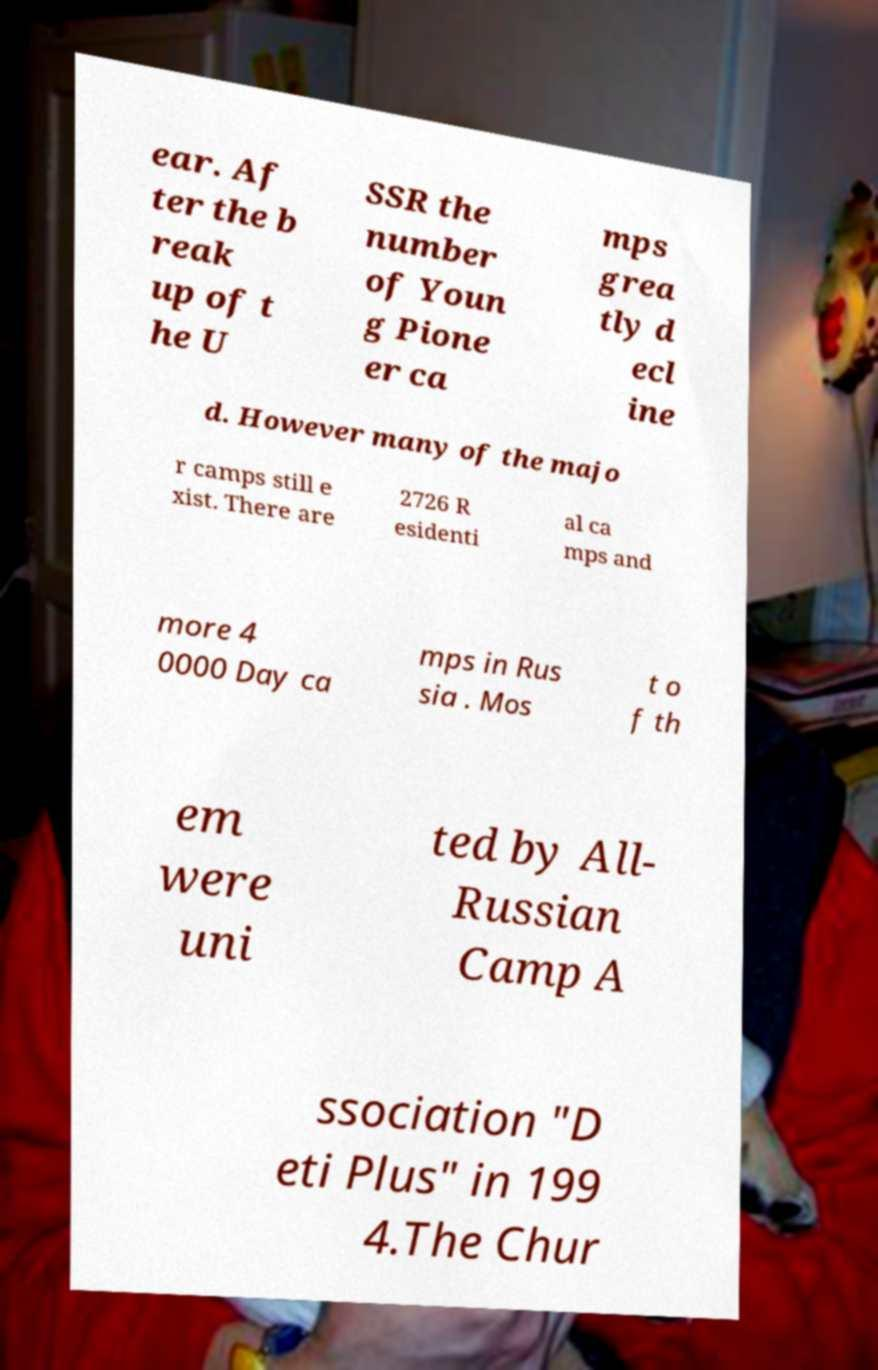There's text embedded in this image that I need extracted. Can you transcribe it verbatim? ear. Af ter the b reak up of t he U SSR the number of Youn g Pione er ca mps grea tly d ecl ine d. However many of the majo r camps still e xist. There are 2726 R esidenti al ca mps and more 4 0000 Day ca mps in Rus sia . Mos t o f th em were uni ted by All- Russian Camp A ssociation "D eti Plus" in 199 4.The Chur 